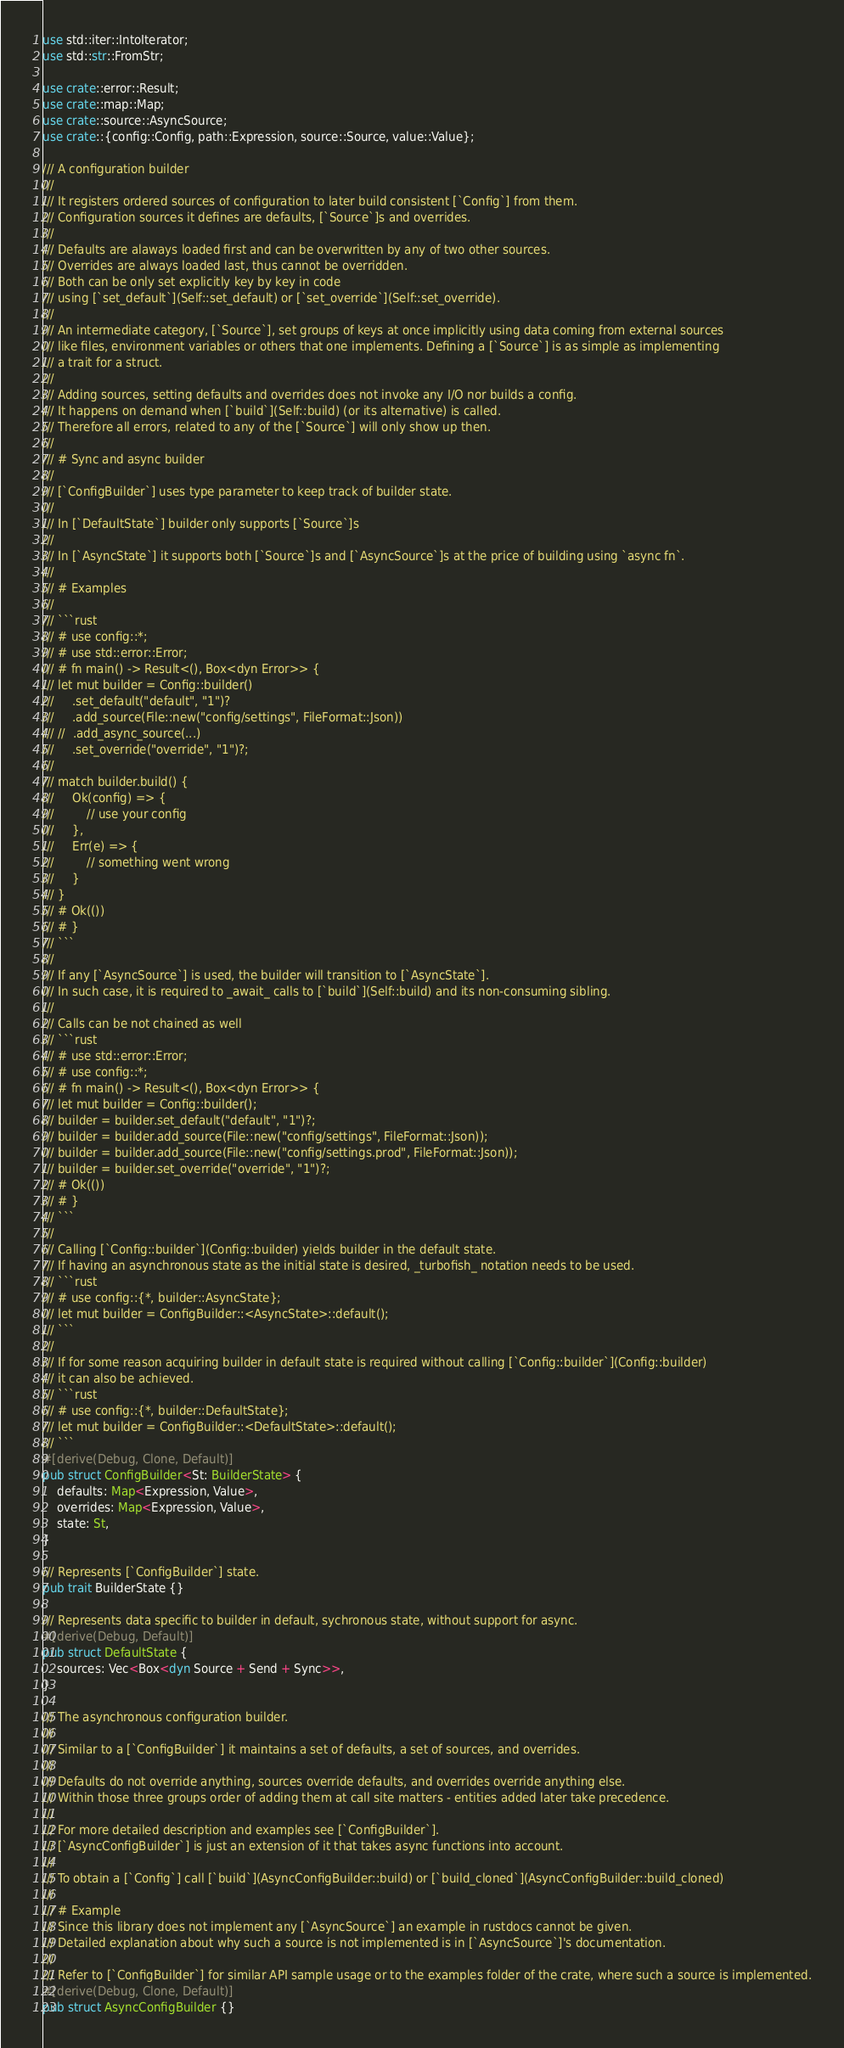<code> <loc_0><loc_0><loc_500><loc_500><_Rust_>use std::iter::IntoIterator;
use std::str::FromStr;

use crate::error::Result;
use crate::map::Map;
use crate::source::AsyncSource;
use crate::{config::Config, path::Expression, source::Source, value::Value};

/// A configuration builder
///
/// It registers ordered sources of configuration to later build consistent [`Config`] from them.
/// Configuration sources it defines are defaults, [`Source`]s and overrides.
///
/// Defaults are alaways loaded first and can be overwritten by any of two other sources.
/// Overrides are always loaded last, thus cannot be overridden.
/// Both can be only set explicitly key by key in code
/// using [`set_default`](Self::set_default) or [`set_override`](Self::set_override).
///
/// An intermediate category, [`Source`], set groups of keys at once implicitly using data coming from external sources
/// like files, environment variables or others that one implements. Defining a [`Source`] is as simple as implementing
/// a trait for a struct.
///
/// Adding sources, setting defaults and overrides does not invoke any I/O nor builds a config.
/// It happens on demand when [`build`](Self::build) (or its alternative) is called.
/// Therefore all errors, related to any of the [`Source`] will only show up then.
///
/// # Sync and async builder
///
/// [`ConfigBuilder`] uses type parameter to keep track of builder state.
///
/// In [`DefaultState`] builder only supports [`Source`]s
///
/// In [`AsyncState`] it supports both [`Source`]s and [`AsyncSource`]s at the price of building using `async fn`.
///
/// # Examples
///
/// ```rust
/// # use config::*;
/// # use std::error::Error;
/// # fn main() -> Result<(), Box<dyn Error>> {
/// let mut builder = Config::builder()
///     .set_default("default", "1")?
///     .add_source(File::new("config/settings", FileFormat::Json))
/// //  .add_async_source(...)
///     .set_override("override", "1")?;
///
/// match builder.build() {
///     Ok(config) => {
///         // use your config
///     },
///     Err(e) => {
///         // something went wrong
///     }
/// }
/// # Ok(())
/// # }
/// ```
///
/// If any [`AsyncSource`] is used, the builder will transition to [`AsyncState`].
/// In such case, it is required to _await_ calls to [`build`](Self::build) and its non-consuming sibling.
///
/// Calls can be not chained as well
/// ```rust
/// # use std::error::Error;
/// # use config::*;
/// # fn main() -> Result<(), Box<dyn Error>> {
/// let mut builder = Config::builder();
/// builder = builder.set_default("default", "1")?;
/// builder = builder.add_source(File::new("config/settings", FileFormat::Json));
/// builder = builder.add_source(File::new("config/settings.prod", FileFormat::Json));
/// builder = builder.set_override("override", "1")?;
/// # Ok(())
/// # }
/// ```
///
/// Calling [`Config::builder`](Config::builder) yields builder in the default state.
/// If having an asynchronous state as the initial state is desired, _turbofish_ notation needs to be used.
/// ```rust
/// # use config::{*, builder::AsyncState};
/// let mut builder = ConfigBuilder::<AsyncState>::default();
/// ```
///
/// If for some reason acquiring builder in default state is required without calling [`Config::builder`](Config::builder)
/// it can also be achieved.
/// ```rust
/// # use config::{*, builder::DefaultState};
/// let mut builder = ConfigBuilder::<DefaultState>::default();
/// ```
#[derive(Debug, Clone, Default)]
pub struct ConfigBuilder<St: BuilderState> {
    defaults: Map<Expression, Value>,
    overrides: Map<Expression, Value>,
    state: St,
}

/// Represents [`ConfigBuilder`] state.
pub trait BuilderState {}

/// Represents data specific to builder in default, sychronous state, without support for async.
#[derive(Debug, Default)]
pub struct DefaultState {
    sources: Vec<Box<dyn Source + Send + Sync>>,
}

/// The asynchronous configuration builder.
///
/// Similar to a [`ConfigBuilder`] it maintains a set of defaults, a set of sources, and overrides.
///
/// Defaults do not override anything, sources override defaults, and overrides override anything else.
/// Within those three groups order of adding them at call site matters - entities added later take precedence.
///
/// For more detailed description and examples see [`ConfigBuilder`].
/// [`AsyncConfigBuilder`] is just an extension of it that takes async functions into account.
///
/// To obtain a [`Config`] call [`build`](AsyncConfigBuilder::build) or [`build_cloned`](AsyncConfigBuilder::build_cloned)
///
/// # Example
/// Since this library does not implement any [`AsyncSource`] an example in rustdocs cannot be given.
/// Detailed explanation about why such a source is not implemented is in [`AsyncSource`]'s documentation.
///
/// Refer to [`ConfigBuilder`] for similar API sample usage or to the examples folder of the crate, where such a source is implemented.
#[derive(Debug, Clone, Default)]
pub struct AsyncConfigBuilder {}
</code> 